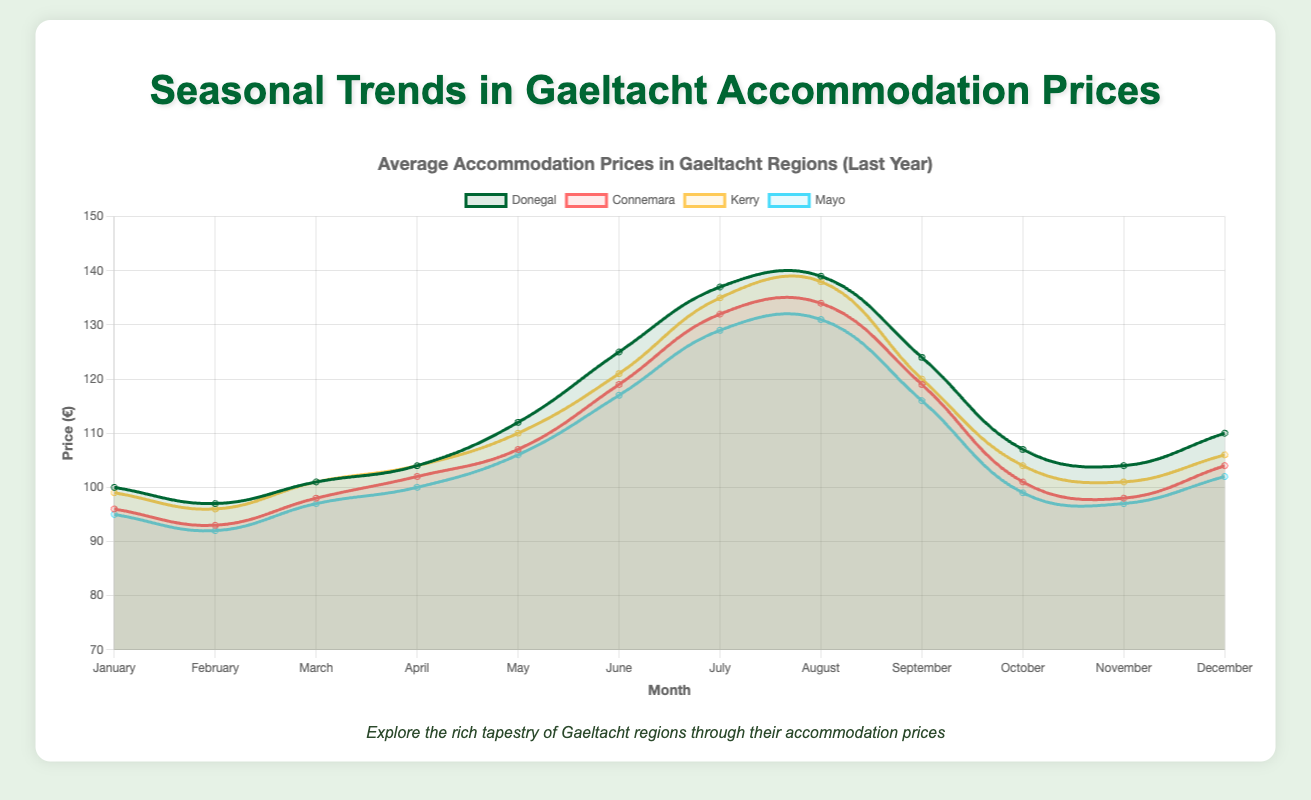Which region has the highest accommodation prices in August? To find the region with the highest prices in August, look at the plotted data points for August across all regions and identify the highest value. Donegal has the highest price in August with a peak of 139 euros.
Answer: Donegal How do the June prices in Kerry compare to those in Mayo? To compare the June prices between Kerry and Mayo, find the plotted value for June in each region. Kerry has a price of 121 euros whereas Mayo has 117 euros. Thus, Kerry's June prices are slightly higher than Mayo's.
Answer: Kerry has higher June prices What is the average price difference between January and July for the Connemara region? To find the average price difference, calculate the January price and July price for Connemara: January is 96 euros and July is 132 euros. Then, subtract January from July: 132 - 96 = 36 euros.
Answer: 36 euros In which month did Donegal see the lowest accommodation prices over the past decade? Identify the plotted values for each month in Donegal and find the month with the lowest value. January of the first year has the lowest value at 85 euros.
Answer: January Which two regions have similar price trends for the month of September? Analyze the plotted values for September across all regions and look for two regions whose lines are close together in height. Both Kerry and Mayo have similar prices in September at 120 and 116 euros, respectively.
Answer: Kerry and Mayo During which month is the price difference the greatest between Kerry and Donegal? Examine the difference in plotted prices between Kerry and Donegal for each month. The greatest difference is in August, where Donegal is at 139 euros and Kerry is at 138 euros, a 1-euro difference.
Answer: August Which region showed the steepest increase in prices from February to March? Look at the plotted data points for February and March for each region and calculate the difference. Donegal increased from 97 euros in February to 101 euros in March, a 4-euro increase, which is steepest among regions.
Answer: Donegal During which month do all regions show a peak in prices? Identify the month where all regions have their highest plotted values. All regions peak in July, with the highest prices recorded.
Answer: July How are the November prices for Donegal different from those in Kerry? Compare the plotted prices for November between Donegal and Kerry. Donegal's price in November is 104 euros while Kerry's is 101 euros, making Donegal's November prices 3 euros higher than Kerry's.
Answer: 3 euros What is the visual difference in the price trend lines for Connemara and Mayo during the summer months (June-August)? Observe the slope and height of the trend lines for Connemara and Mayo from June to August. Connemara rises from 119 to 134 euros (15-euro increase), while Mayo rises from 117 to 131 euros (14-euro increase). Connemara's trend is slightly steeper and higher visually.
Answer: Connemara steeper and higher 